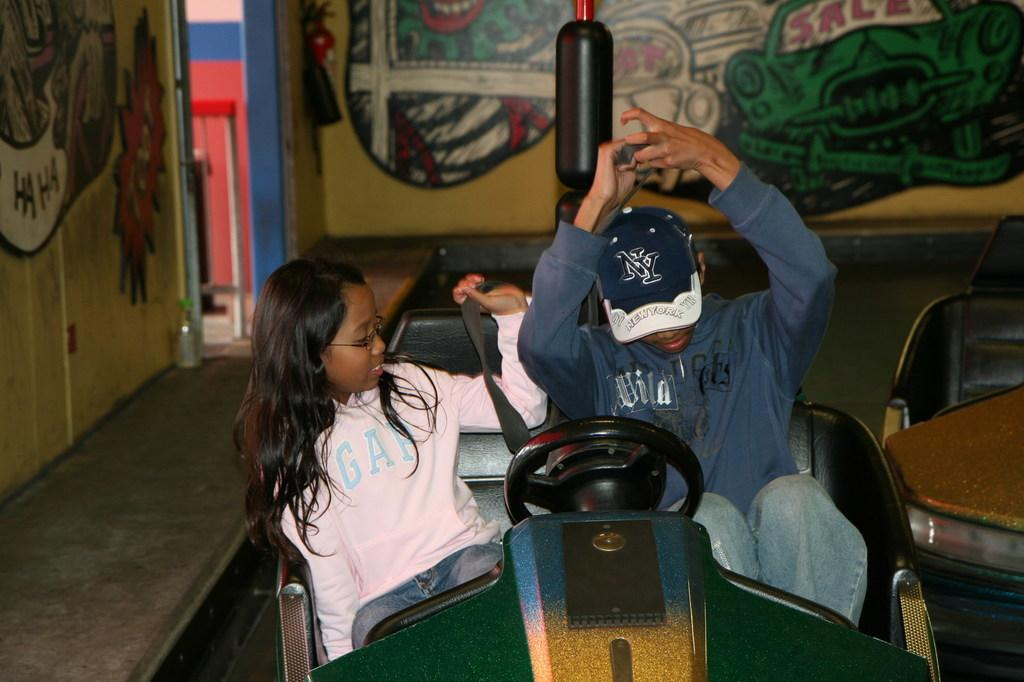<image>
Render a clear and concise summary of the photo. Two kids sitting in a toy car and the boy is wearing a baseball cap with the logo NY on the front. 